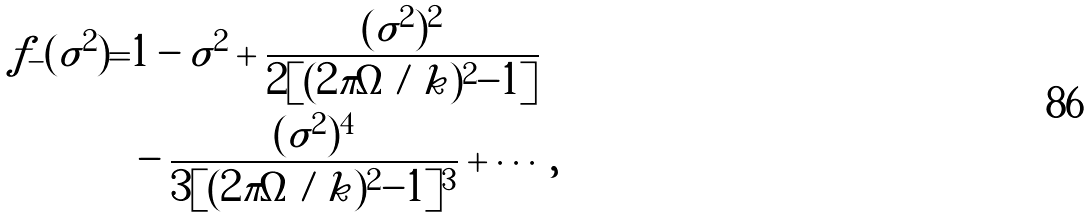Convert formula to latex. <formula><loc_0><loc_0><loc_500><loc_500>f _ { - } ( \tilde { \sigma } ^ { 2 } ) = & 1 - \tilde { \sigma } ^ { 2 } + \frac { ( \tilde { \sigma } ^ { 2 } ) ^ { 2 } } { 2 [ ( 2 \pi \Omega / \tilde { k } ) ^ { 2 } - 1 ] } \\ & - \frac { ( \tilde { \sigma } ^ { 2 } ) ^ { 4 } } { 3 [ ( 2 \pi \Omega / \tilde { k } ) ^ { 2 } - 1 ] ^ { 3 } } + \cdots ,</formula> 